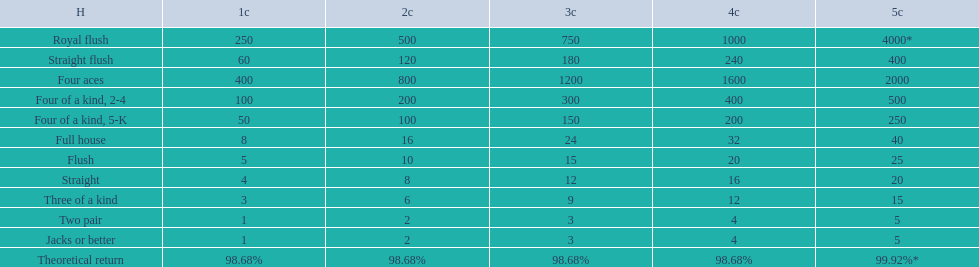What are the different hands? Royal flush, Straight flush, Four aces, Four of a kind, 2-4, Four of a kind, 5-K, Full house, Flush, Straight, Three of a kind, Two pair, Jacks or better. Which hands have a higher standing than a straight? Royal flush, Straight flush, Four aces, Four of a kind, 2-4, Four of a kind, 5-K, Full house, Flush. Of these, which hand is the next highest after a straight? Flush. 